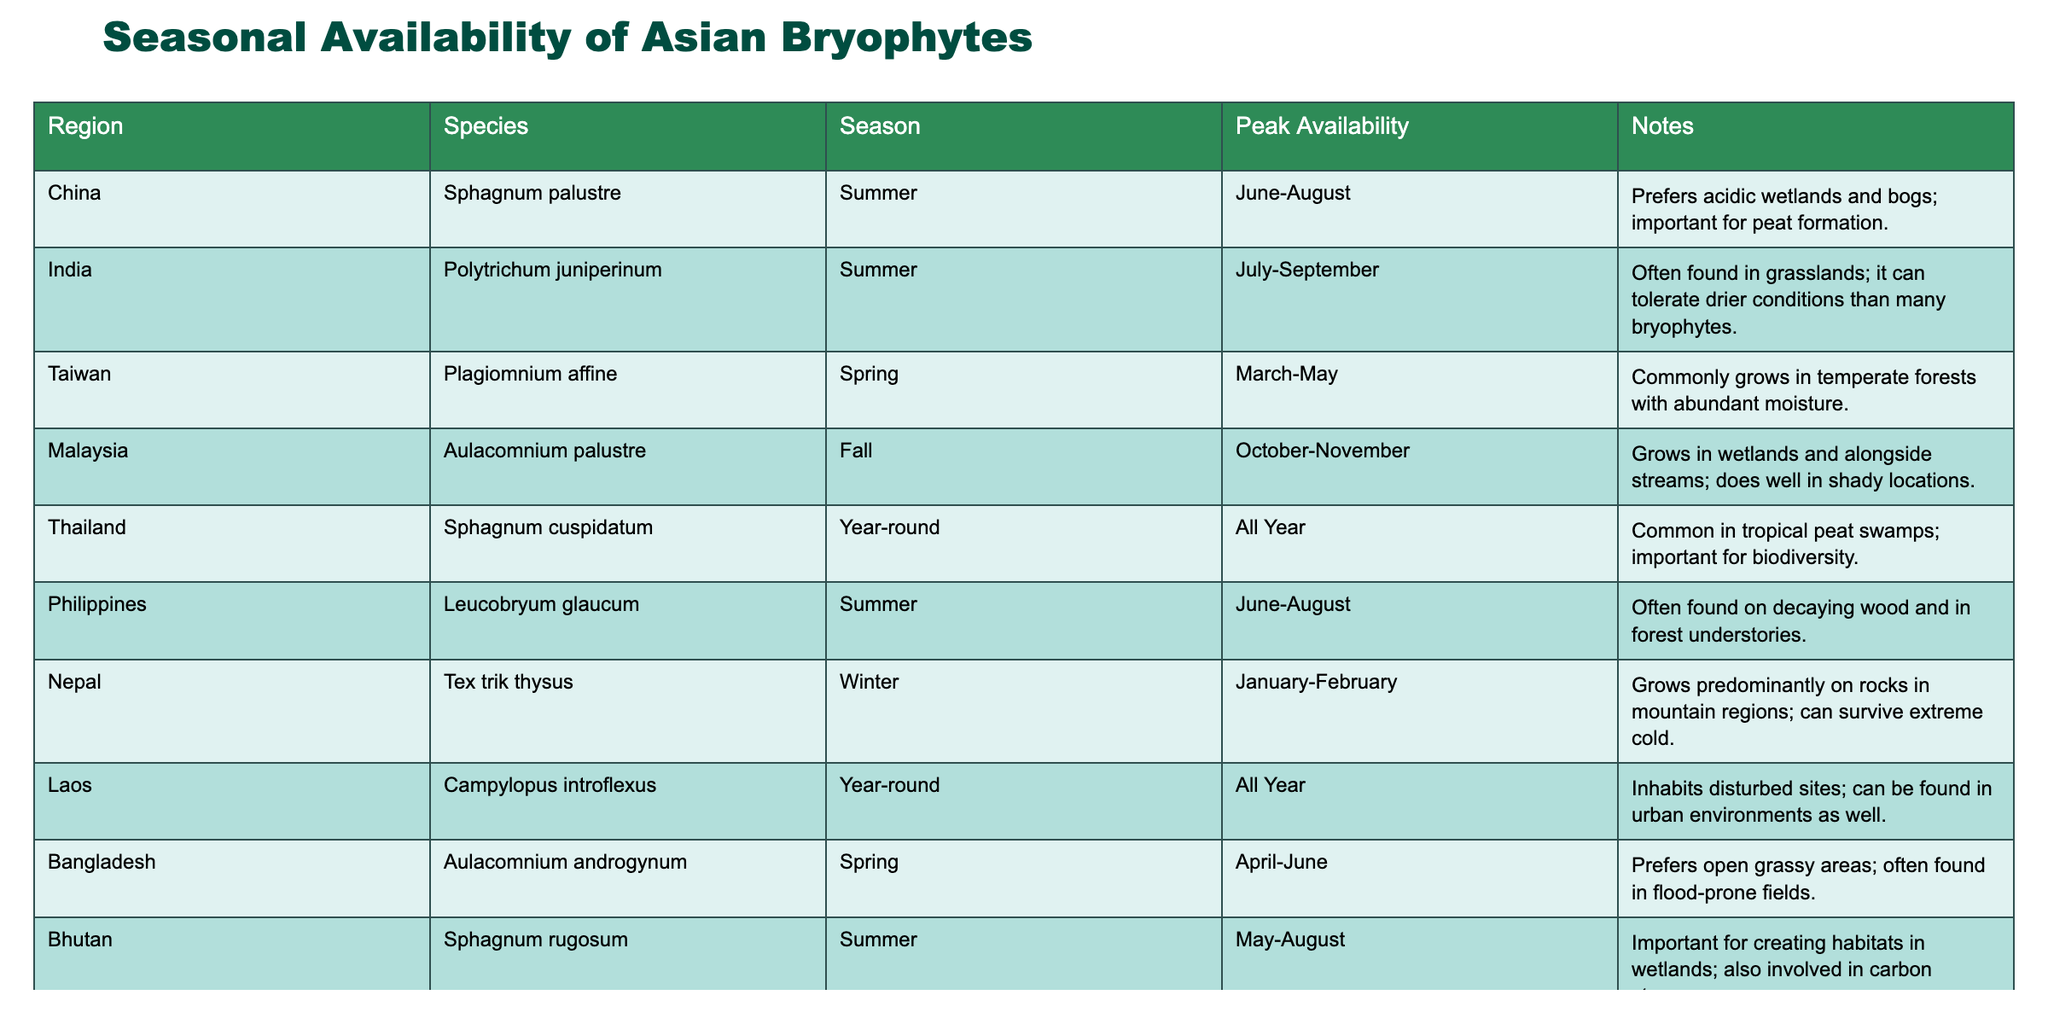What is the peak availability season for Sphagnum palustre in China? The table indicates that Sphagnum palustre peaks in availability during the summer months, specifically from June to August.
Answer: Summer Which species is available year-round in Thailand? The table shows that Sphagnum cuspidatum has year-round availability in Thailand, meaning it can be found regardless of the season.
Answer: Sphagnum cuspidatum In which season is Aulacomnium androgynum most available in Bangladesh? The table states that Aulacomnium androgynum peaks in availability during the spring season, specifically from April to June.
Answer: Spring How many species available in the summer season are also found in forest environments? Referring to the table, Sphagnum palustre and Leucobryum glaucum are both available in summer and found in forest environments, while Aulacomnium androgynum prefers open grassy areas. The answer is 2.
Answer: 2 Is Plagiomnium affine found in the same season as Aulacomnium palustre? By checking the table, Plagiomnium affine is available in spring, while Aulacomnium palustre is available in fall. Therefore, they are not in the same season.
Answer: No Which Asian region has the highest number of bryophyte species available in summer? Looking at the table, both China and Bhutan have two species each available in summer (Sphagnum palustre in China and Sphagnum rugosum in Bhutan), while other regions have one or none. Hence, there is a tie between these two regions.
Answer: China and Bhutan What is the total number of species listed in the table? Counting the entries in the table, there are 10 species mentioned across different regions, each representing a unique data point.
Answer: 10 In which region is Polytrichum juniperinum found, and how does its peak availability time compare to Sphagnum rugosum? The table shows that Polytrichum juniperinum is located in India with a peak availability from July to September, while Sphagnum rugosum is found in Bhutan with a peak from May to August, indicating that Polytrichum's peak is later than Sphagnum's.
Answer: India; Polytrichum peak is later Which species has the shortest peak availability period and in which region is it located? The species Tex trik thysus from Nepal shows peak availability only during January and February, making it the shortest peak availability period with just two months.
Answer: Tex trik thysus; Nepal Which region features Aulacomnium palustre, and what is its peak availability time? According to the table, Aulacomnium palustre is featured in Malaysia, with peak availability during October and November.
Answer: Malaysia; October-November 